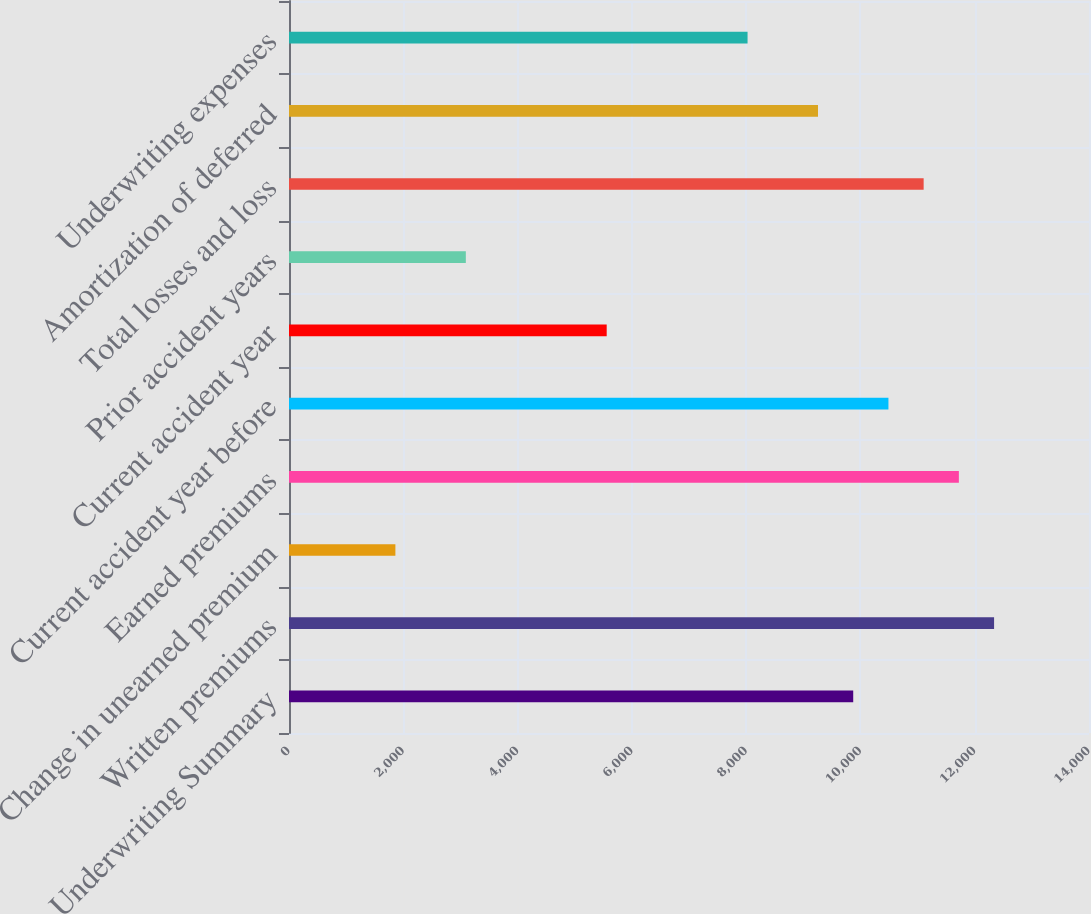Convert chart to OTSL. <chart><loc_0><loc_0><loc_500><loc_500><bar_chart><fcel>Underwriting Summary<fcel>Written premiums<fcel>Change in unearned premium<fcel>Earned premiums<fcel>Current accident year before<fcel>Current accident year<fcel>Prior accident years<fcel>Total losses and loss<fcel>Amortization of deferred<fcel>Underwriting expenses<nl><fcel>9873.8<fcel>12339<fcel>1861.9<fcel>11722.7<fcel>10490.1<fcel>5559.7<fcel>3094.5<fcel>11106.4<fcel>9257.5<fcel>8024.9<nl></chart> 